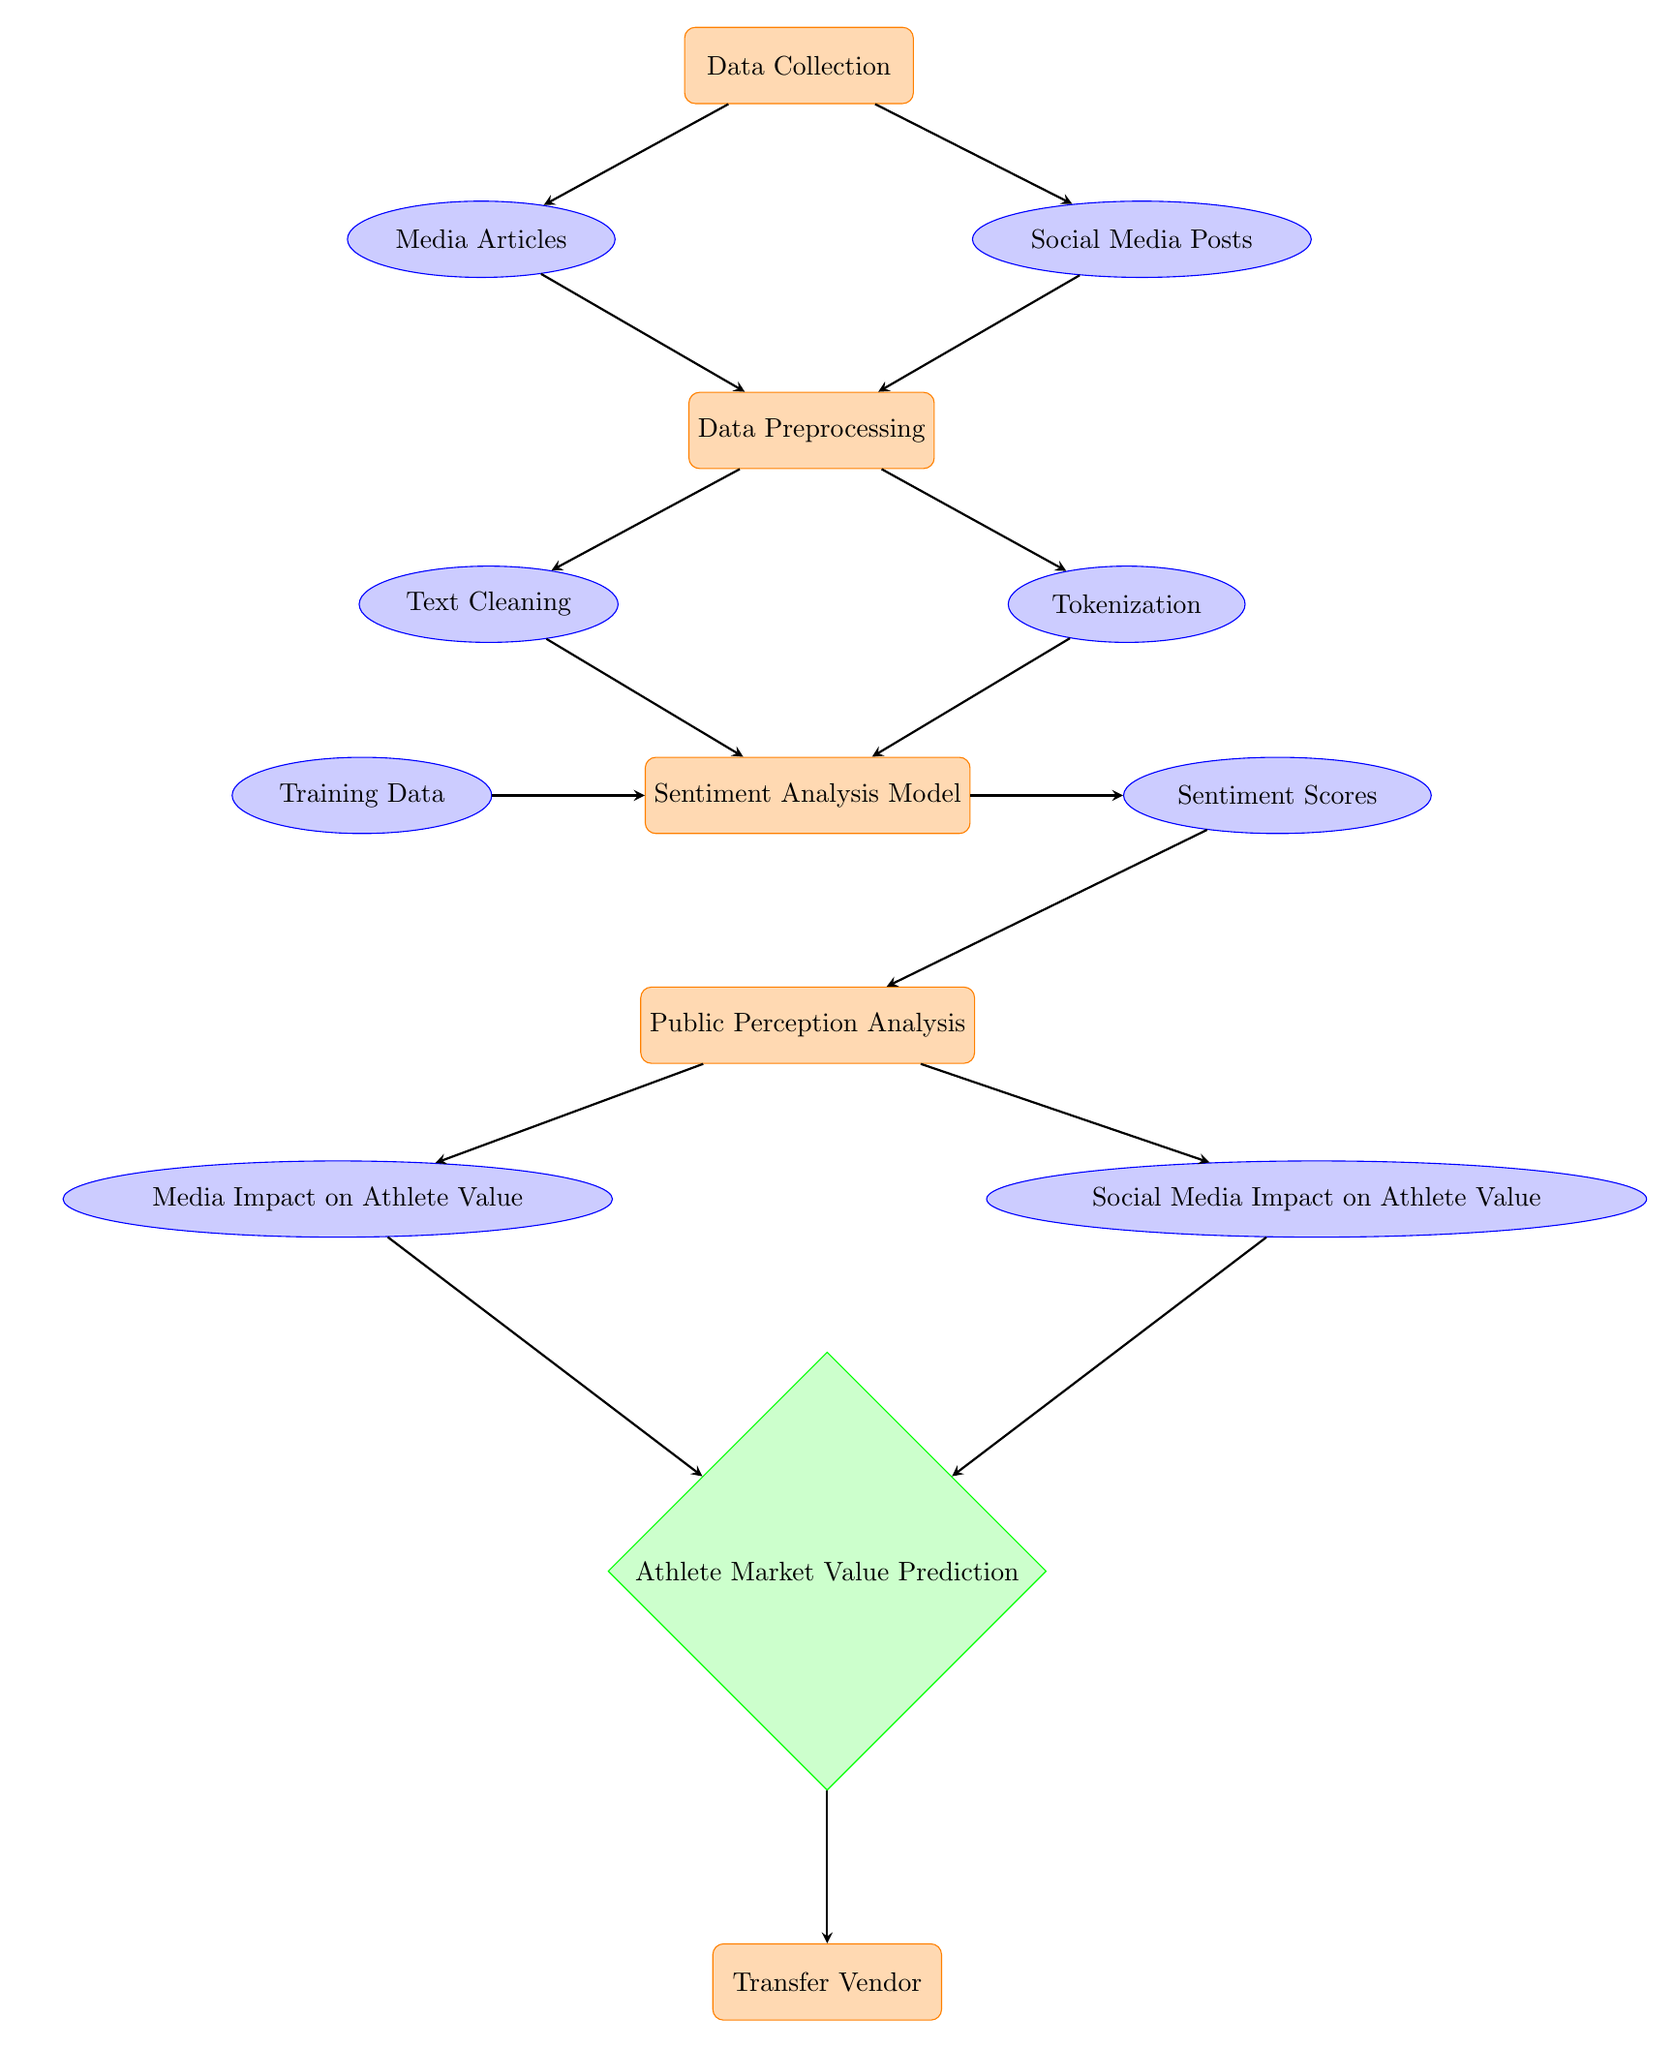What are the two sources of data in this analysis? The diagram shows two data sources as nodes leading from the Data Collection node: Media Articles and Social Media Posts.
Answer: Media Articles, Social Media Posts What process follows after Data Preprocessing? The next step after Data Preprocessing is the Sentiment Analysis Model, indicated by an arrow leading downward from the Preprocessing node.
Answer: Sentiment Analysis Model How many data types are shown in the diagram? The diagram contains four data types: Media Articles, Social Media Posts, Training Data, and Sentiment Scores. Counting these nodes gives a total of four.
Answer: Four Which two impacts are analyzed after sentiment scores? The analysis flows from the scores to two separate nodes: Media Impact on Athlete Value and Social Media Impact on Athlete Value.
Answer: Media Impact on Athlete Value, Social Media Impact on Athlete Value What is the purpose of the Prediction decision node? The Prediction decision node evaluates the impact from Media and Social Media on Athlete Market Value, resulting in a final prediction about the athlete's market value based on collected data and analysis.
Answer: Athlete Market Value Prediction Which process occurs directly after Public Perception Analysis? The diagram shows that after Public Perception Analysis, the next process is Athlete Market Value Prediction, as indicated by the downward arrow from the analysis node.
Answer: Athlete Market Value Prediction What types of processes are indicated in the diagram? In this diagram, processes are represented by nodes styled in orange, including Data Collection, Data Preprocessing, Sentiment Analysis Model, Public Perception Analysis, and Transfer Vendor.
Answer: Five Which data options are utilized for the Sentiment Analysis Model? The Sentiment Analysis Model utilizes Training Data, Sentiment Scores, and the outputs from the Text Cleaning and Tokenization processes, all feeding into it as indicated by the arrows leading to the model.
Answer: Training Data, Sentiment Scores Which node is the final output of the diagram? The final output node at the bottom of the diagram is Transfer Vendor, which follows the Prediction decision node.
Answer: Transfer Vendor 